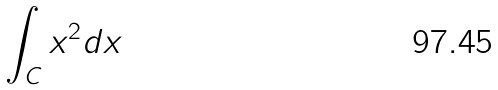Convert formula to latex. <formula><loc_0><loc_0><loc_500><loc_500>\int _ { C } x ^ { 2 } d x</formula> 